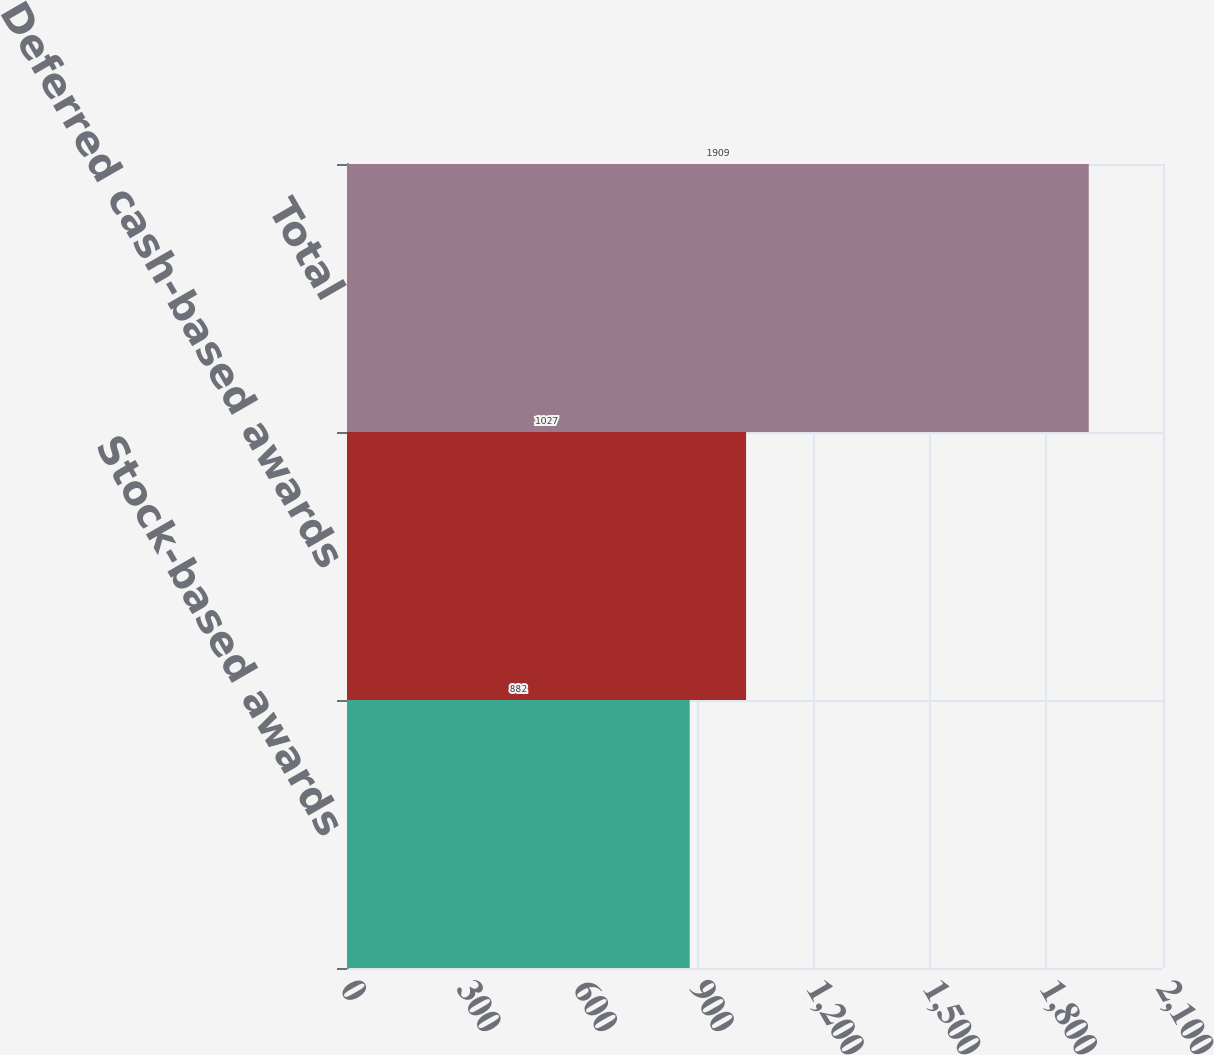Convert chart. <chart><loc_0><loc_0><loc_500><loc_500><bar_chart><fcel>Stock-based awards<fcel>Deferred cash-based awards<fcel>Total<nl><fcel>882<fcel>1027<fcel>1909<nl></chart> 